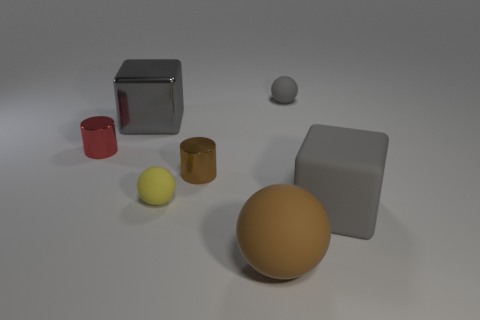Add 2 brown metal cylinders. How many objects exist? 9 Subtract all cubes. How many objects are left? 5 Subtract 1 red cylinders. How many objects are left? 6 Subtract all big gray shiny cubes. Subtract all cylinders. How many objects are left? 4 Add 5 brown rubber spheres. How many brown rubber spheres are left? 6 Add 2 big purple metallic things. How many big purple metallic things exist? 2 